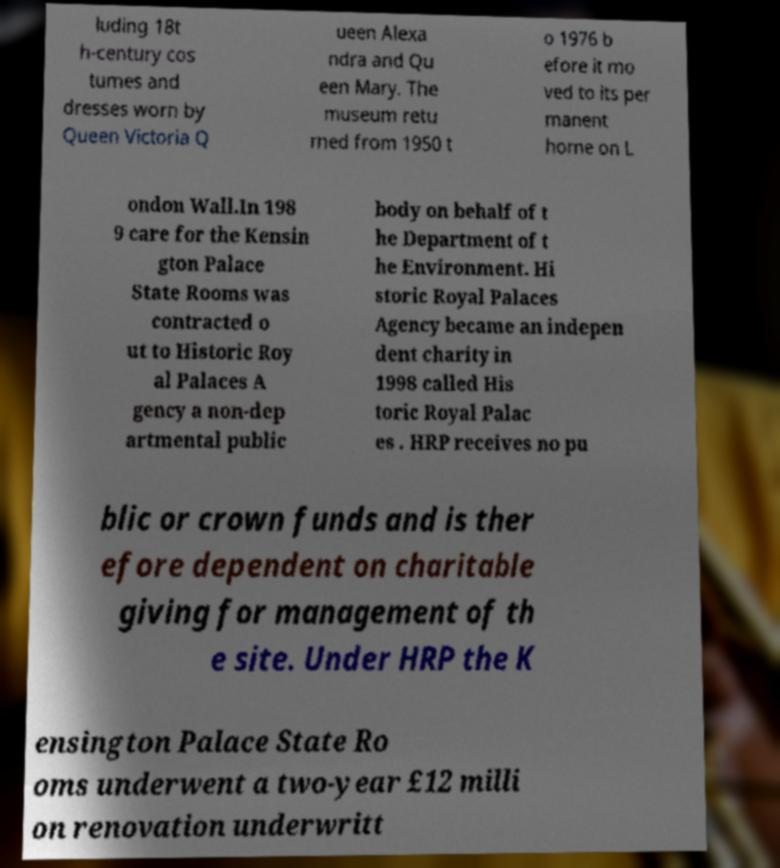Can you accurately transcribe the text from the provided image for me? luding 18t h-century cos tumes and dresses worn by Queen Victoria Q ueen Alexa ndra and Qu een Mary. The museum retu rned from 1950 t o 1976 b efore it mo ved to its per manent home on L ondon Wall.In 198 9 care for the Kensin gton Palace State Rooms was contracted o ut to Historic Roy al Palaces A gency a non-dep artmental public body on behalf of t he Department of t he Environment. Hi storic Royal Palaces Agency became an indepen dent charity in 1998 called His toric Royal Palac es . HRP receives no pu blic or crown funds and is ther efore dependent on charitable giving for management of th e site. Under HRP the K ensington Palace State Ro oms underwent a two-year £12 milli on renovation underwritt 